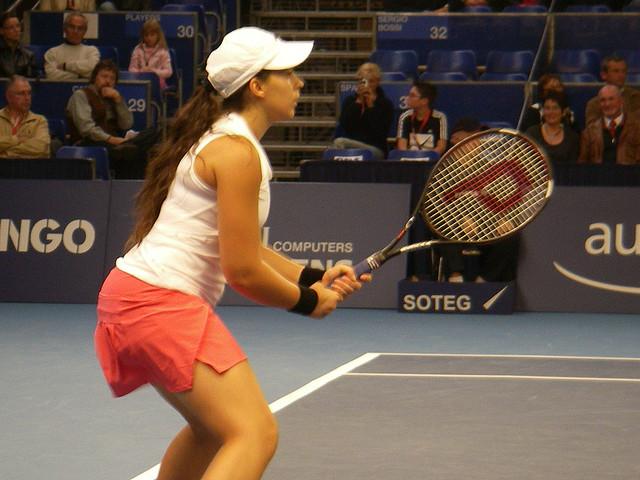What color is the woman's hat?
Give a very brief answer. White. What letter is on the racket?
Answer briefly. P. What color is her skirt?
Answer briefly. Red. 